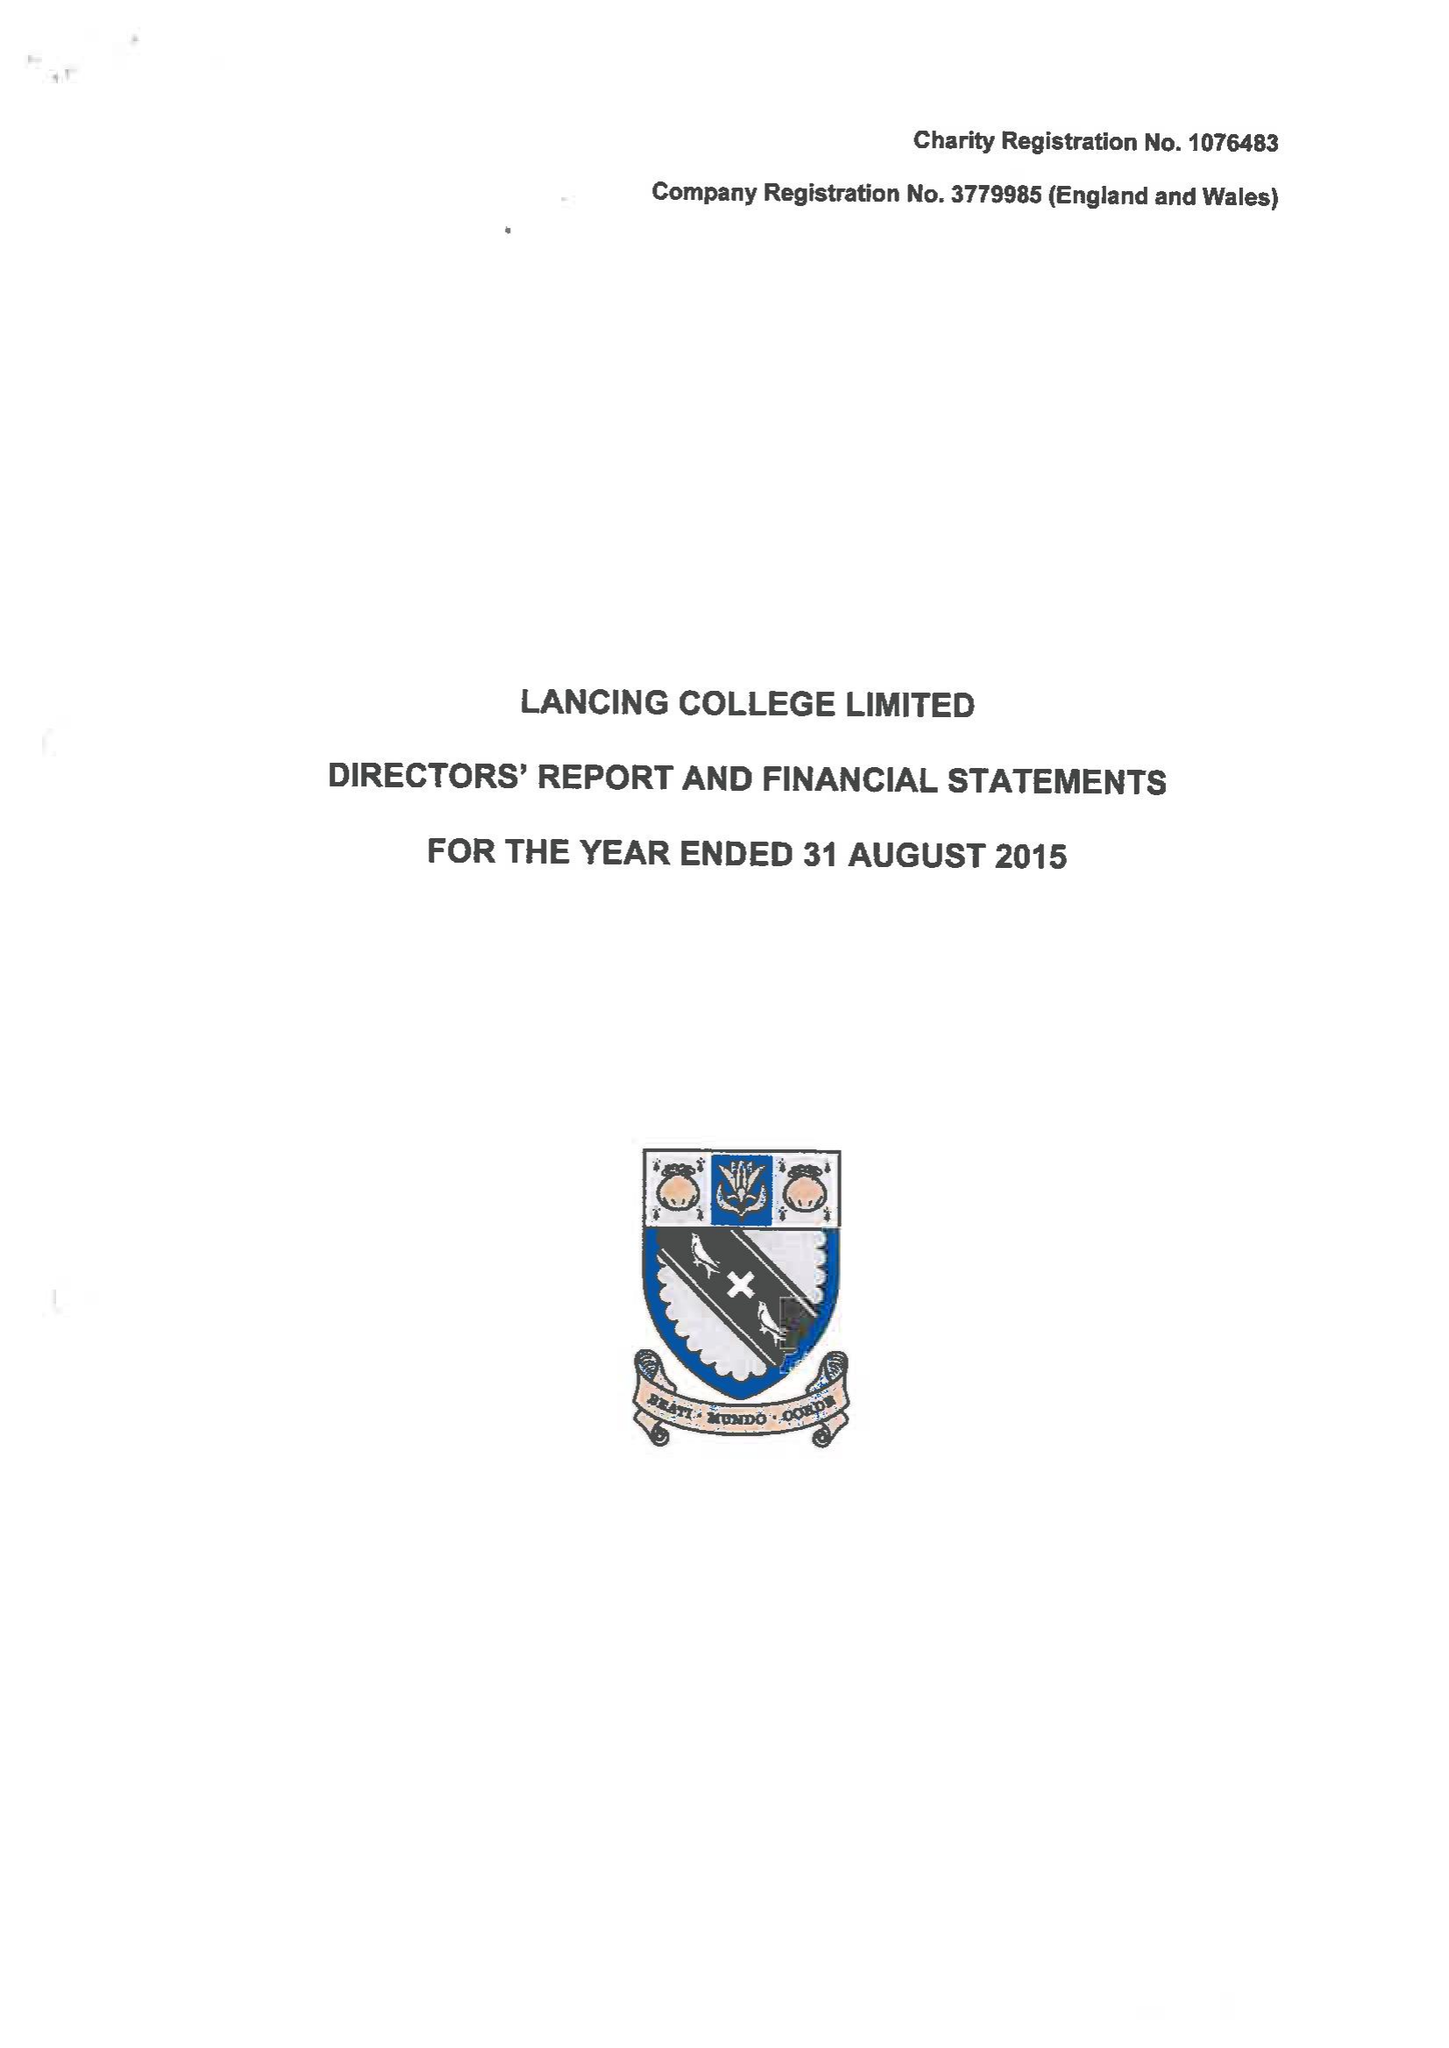What is the value for the charity_number?
Answer the question using a single word or phrase. 1076483 